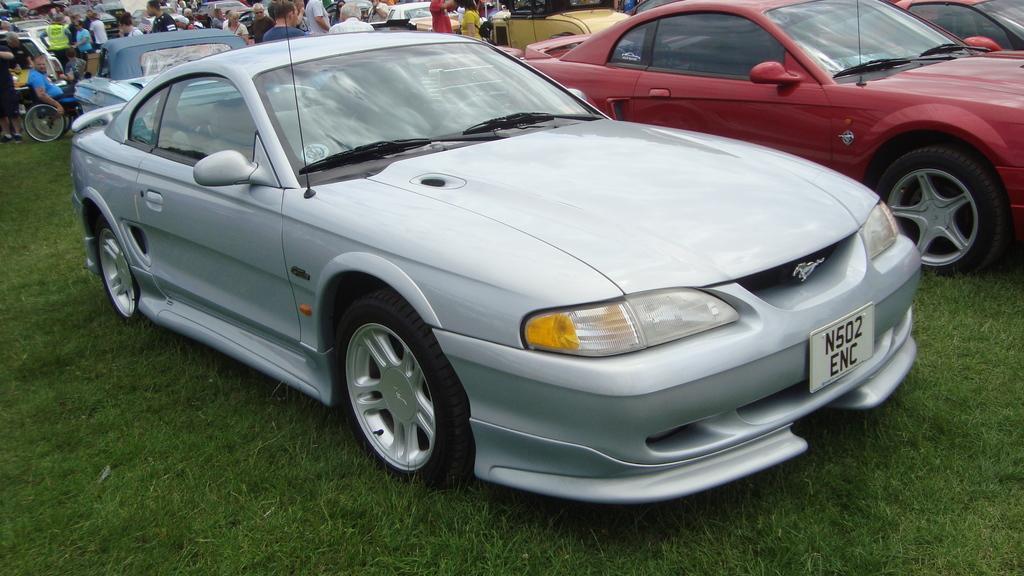Please provide a concise description of this image. In this image we can see there are some vehicles and few people are standing on the surface of the grass. 